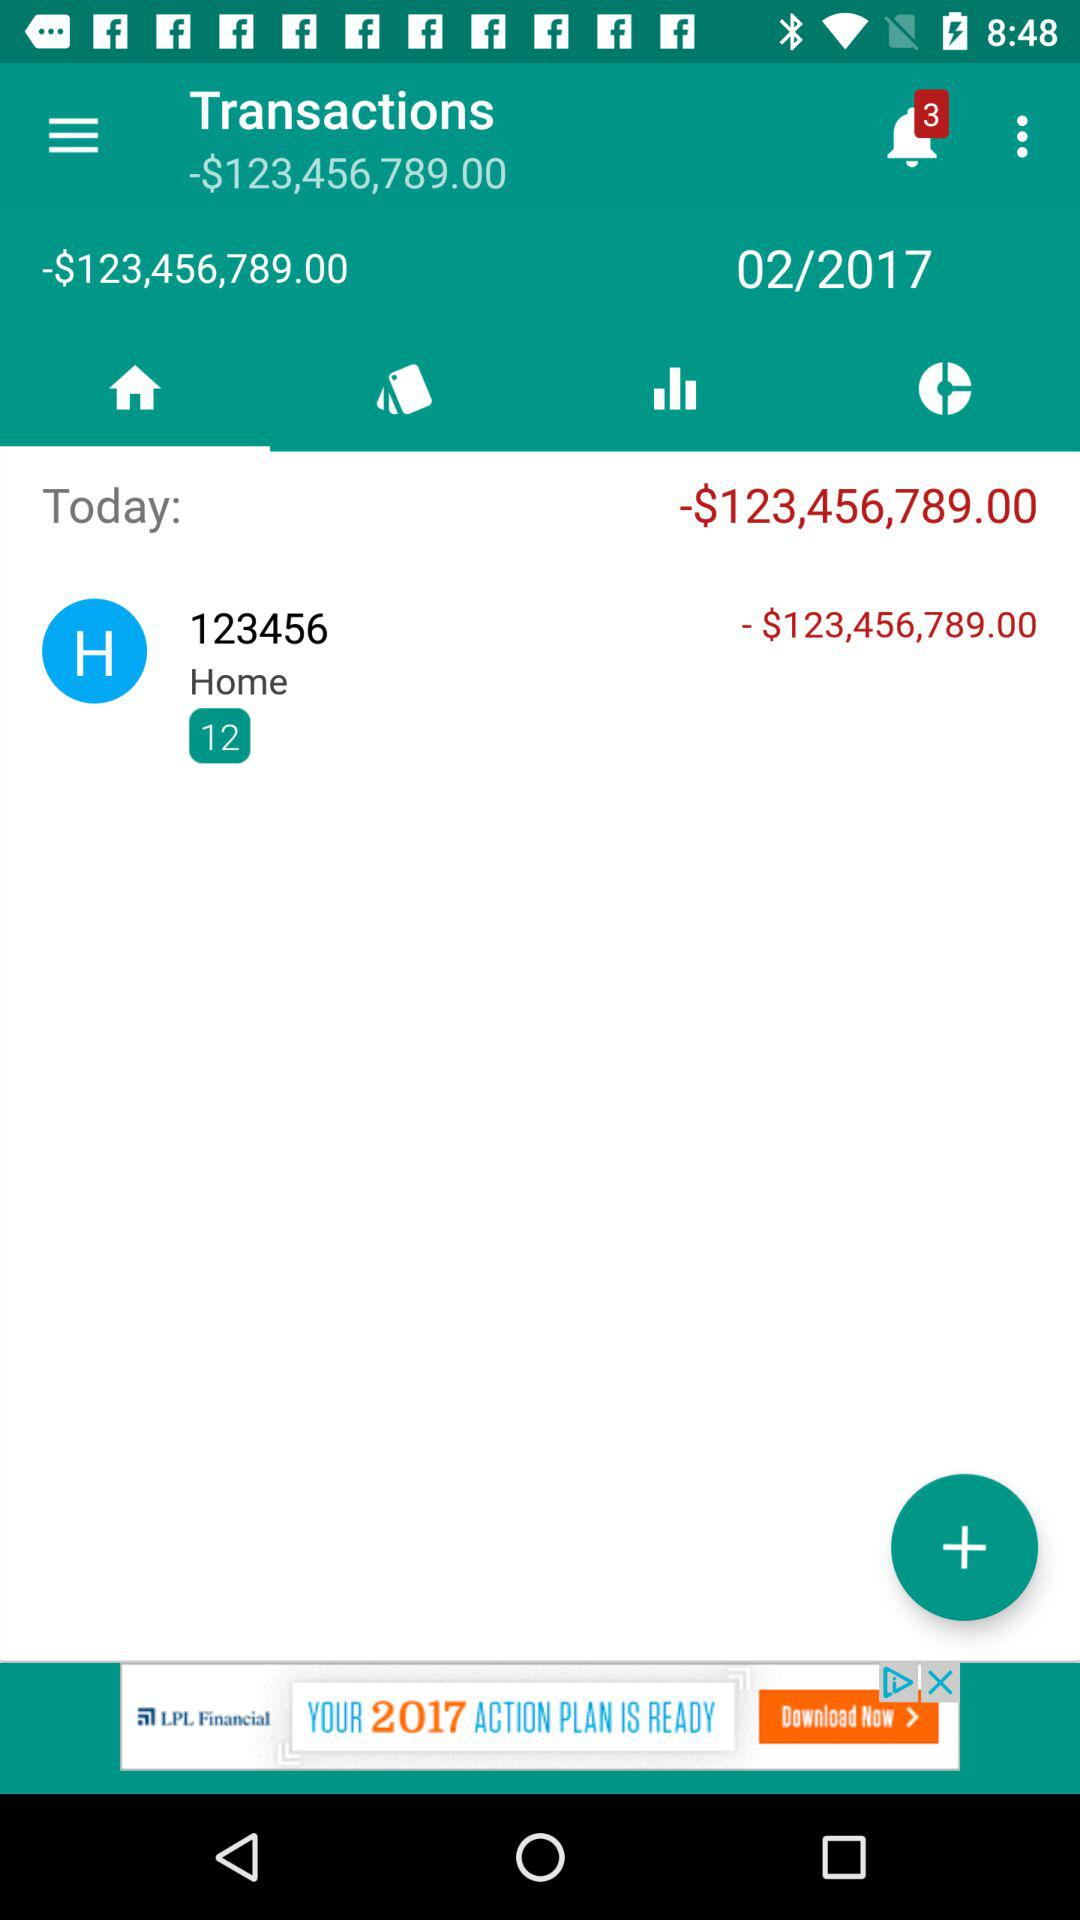Which tab is selected? The selected tab is "Home". 